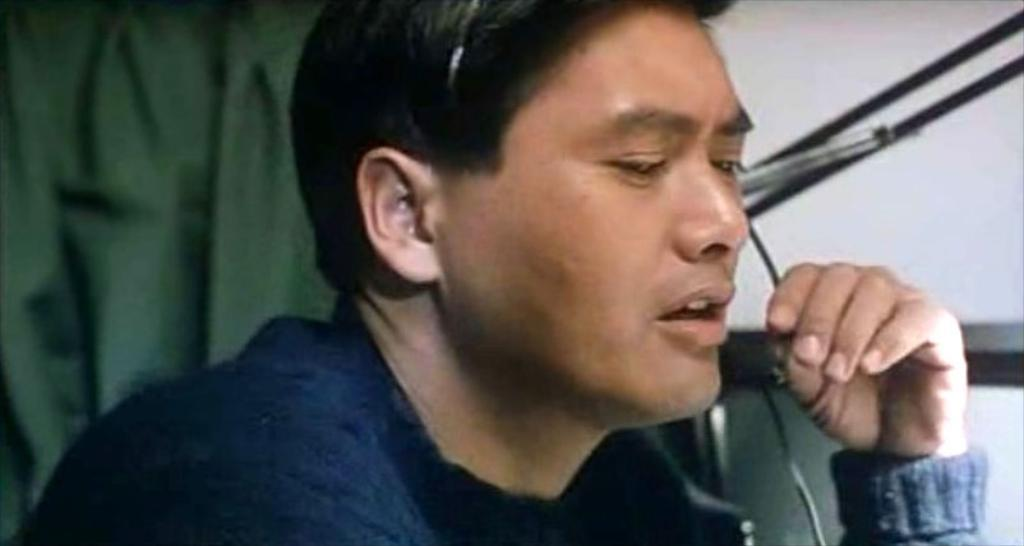What is the main subject of the image? The main subject of the image is a man. What is the man wearing in the image? The man is wearing a headset in the image. What type of food is the kitten eating in the image? There is no kitten or food present in the image. What reward does the man receive for wearing the headset in the image? There is no indication of a reward in the image; the man is simply wearing a headset. 